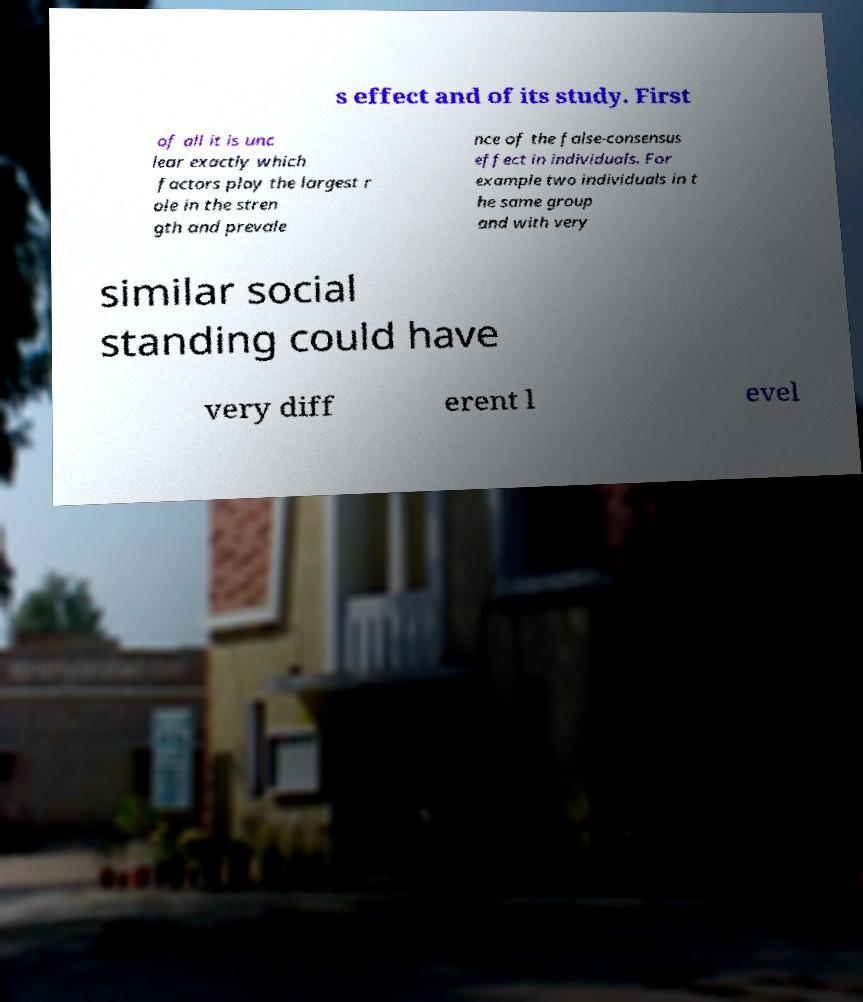For documentation purposes, I need the text within this image transcribed. Could you provide that? s effect and of its study. First of all it is unc lear exactly which factors play the largest r ole in the stren gth and prevale nce of the false-consensus effect in individuals. For example two individuals in t he same group and with very similar social standing could have very diff erent l evel 